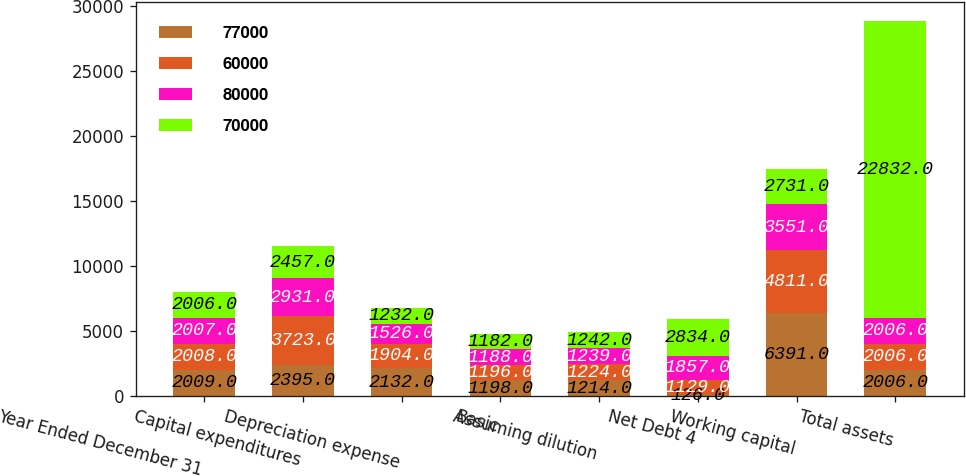<chart> <loc_0><loc_0><loc_500><loc_500><stacked_bar_chart><ecel><fcel>Year Ended December 31<fcel>Capital expenditures<fcel>Depreciation expense<fcel>Basic<fcel>Assuming dilution<fcel>Net Debt 4<fcel>Working capital<fcel>Total assets<nl><fcel>77000<fcel>2009<fcel>2395<fcel>2132<fcel>1198<fcel>1214<fcel>126<fcel>6391<fcel>2006<nl><fcel>60000<fcel>2008<fcel>3723<fcel>1904<fcel>1196<fcel>1224<fcel>1129<fcel>4811<fcel>2006<nl><fcel>80000<fcel>2007<fcel>2931<fcel>1526<fcel>1188<fcel>1239<fcel>1857<fcel>3551<fcel>2006<nl><fcel>70000<fcel>2006<fcel>2457<fcel>1232<fcel>1182<fcel>1242<fcel>2834<fcel>2731<fcel>22832<nl></chart> 